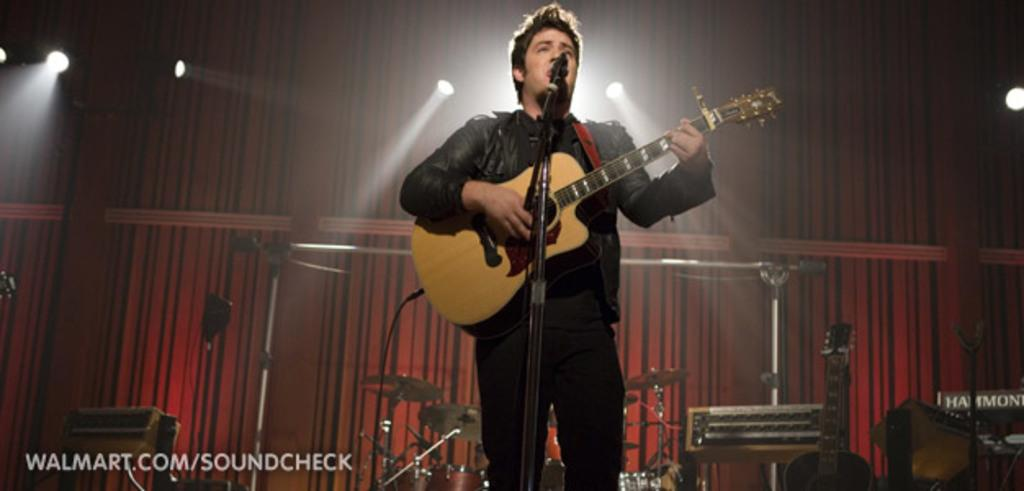What is the man in the image doing? The man is performing a show. What instrument is the man holding? The man is holding a guitar. What is in front of the man for amplifying his voice? There is a microphone in front of the man. What other musical instruments are present in the image? There are musical instruments behind the man. What color is the wall behind the man? The wall behind the man is red in color. What type of gate can be seen in the image? There is no gate present in the image. What shape is the circle that the man is playing in the image? There is no circle in the image; the man is performing on a stage or a flat surface. 